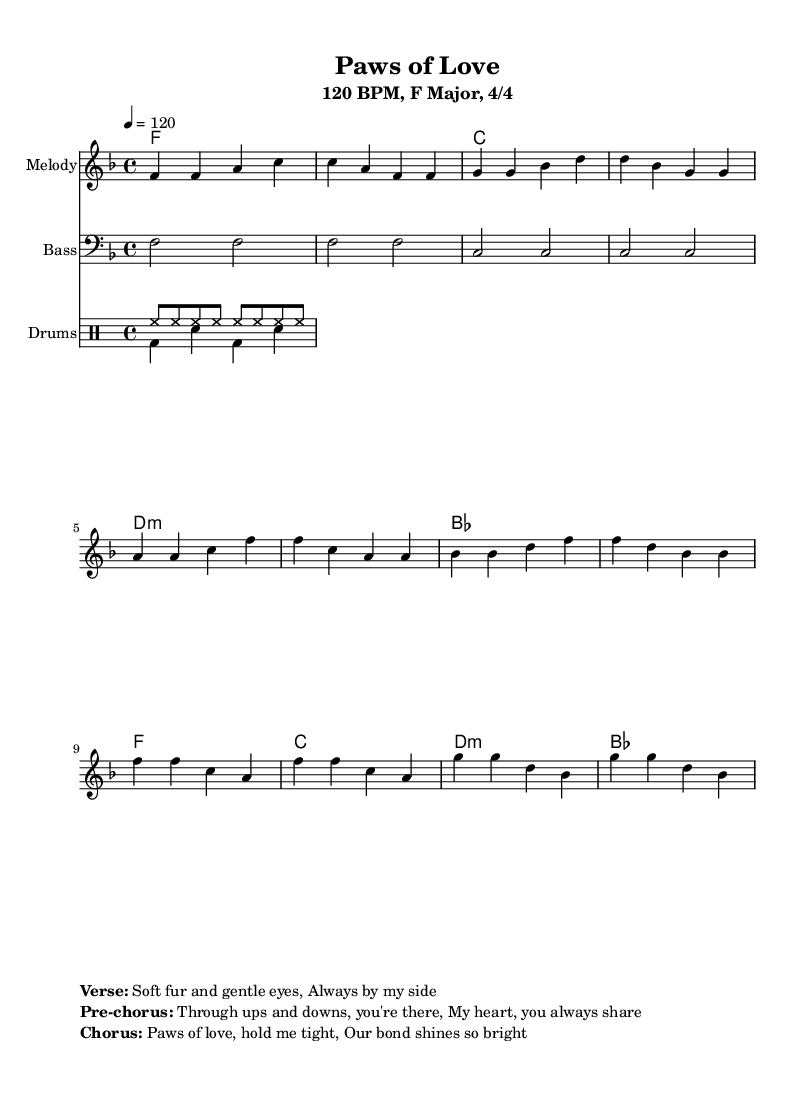What is the key signature of this music? The key signature is observed from the global section where it shows "f \major", indicating that there is one flat (B♭) in the key.
Answer: F major What is the time signature of the piece? The time signature is indicated in the global section as "4/4", meaning there are four beats in a measure and a quarter note gets one beat.
Answer: 4/4 What is the tempo marking of the music? The tempo is indicated in the global section as "4 = 120", which specifies that the quarter note should be played at 120 beats per minute.
Answer: 120 BPM What are the lyrics associated with the chorus? The lyrics for the chorus can be found in the markup section, which states "Paws of love, hold me tight, Our bond shines so bright."
Answer: Paws of love, hold me tight, Our bond shines so bright How many measures are indicated in the melody section? By analyzing the melody section, we see that there are twelve measures in total, with each line representing four measures.
Answer: 12 What is the mood conveyed by the lyrics in the pre-chorus? The pre-chorus lyrics express a sense of togetherness and emotional support, indicating a deep bond between the human and dog.
Answer: Emotional support Which instrument plays the bass part? The bass part is specified in the score under a distinct staff labeled "Bass", where the bass clef is used.
Answer: Bass 